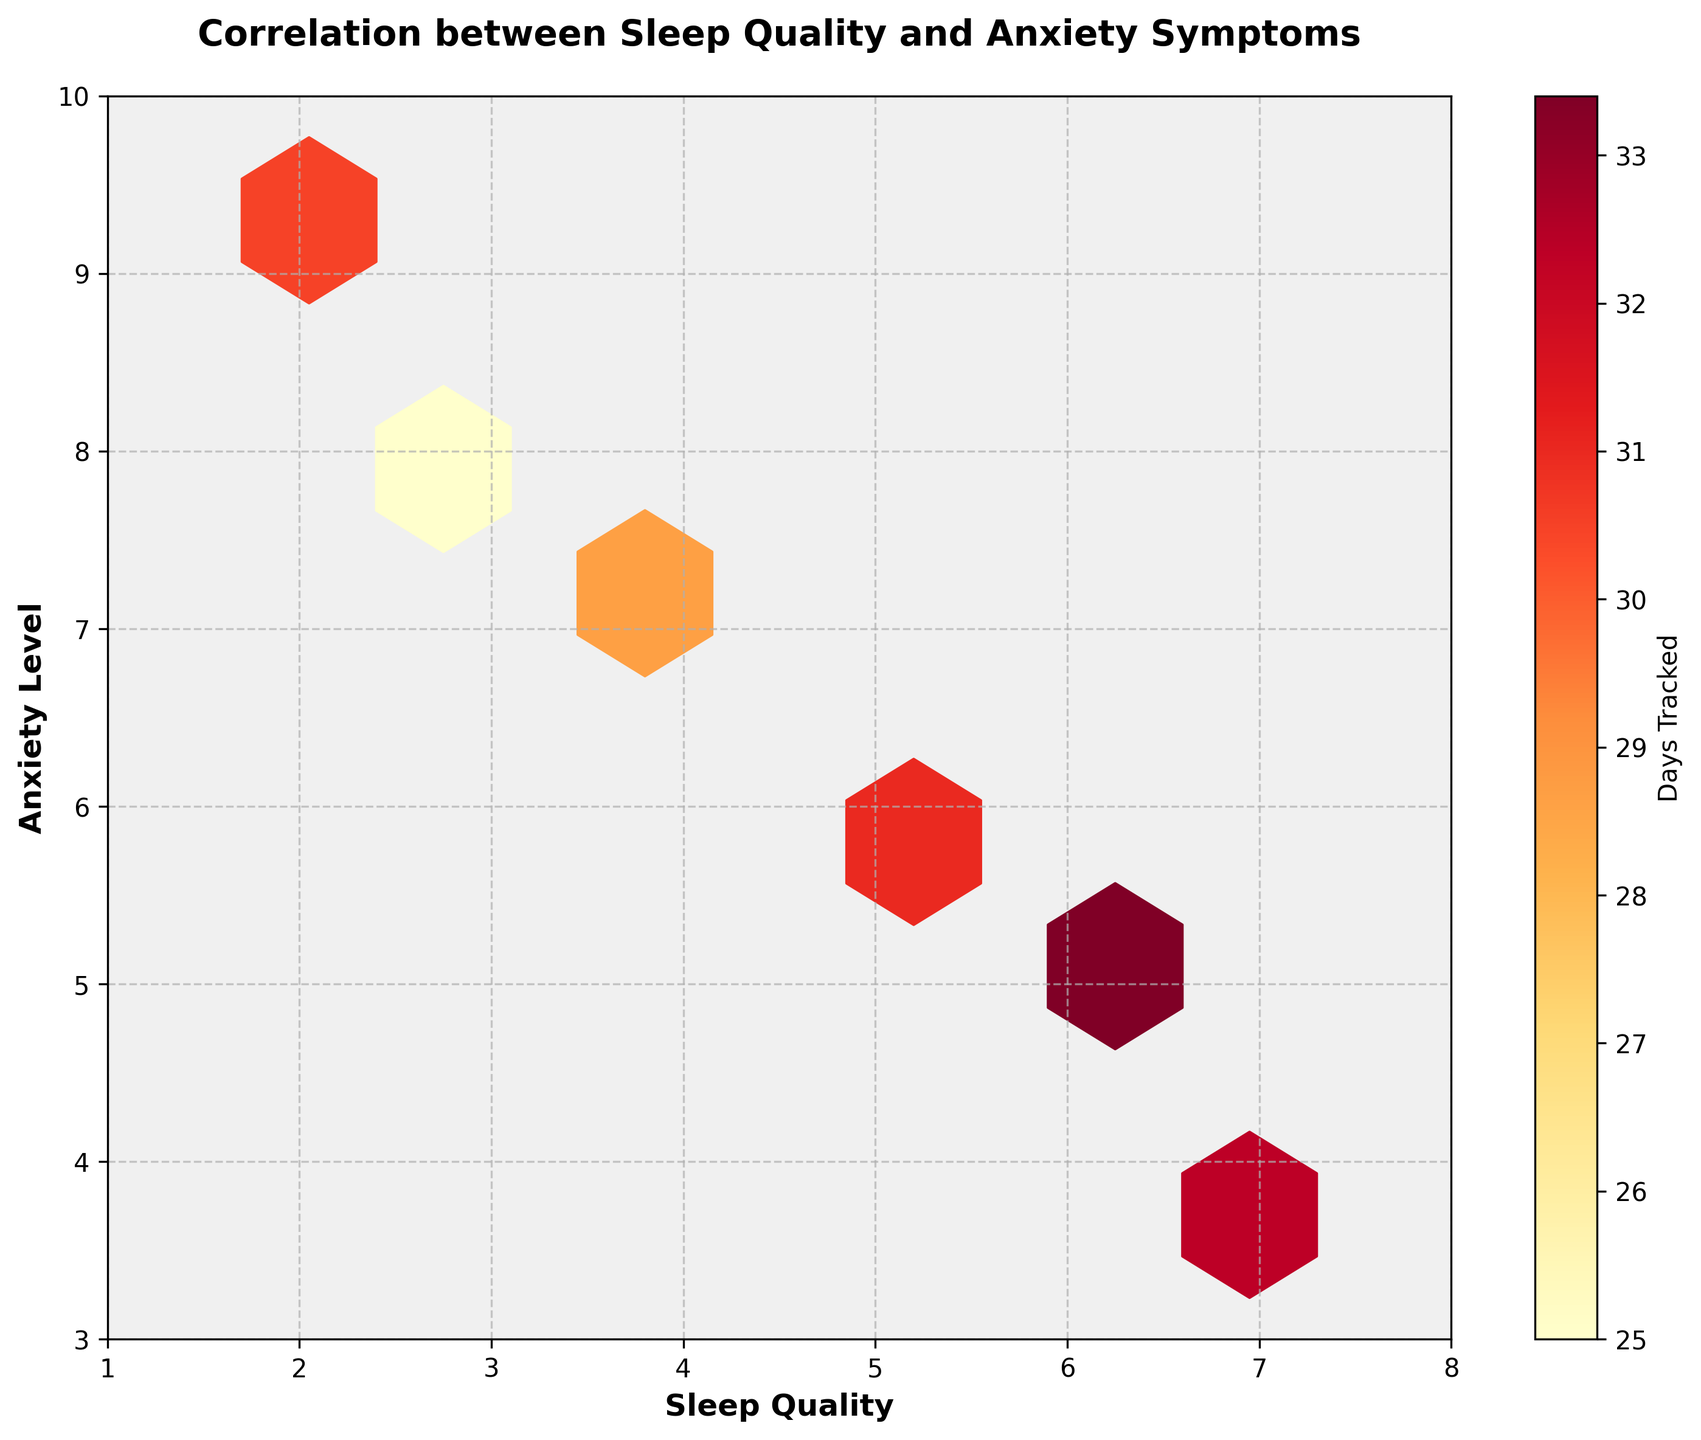What are the labels on the x-axis and y-axis? The x-axis is labeled 'Sleep Quality' and the y-axis is labeled 'Anxiety Level'.
Answer: 'Sleep Quality' and 'Anxiety Level' How many days are tracked according to the color bar? The color bar shows that the data is tracked over 'Days Tracked', and the color gradient ranges from lighter to darker shades.
Answer: 'Days Tracked' Which variable appears on the hexbin grid? 'Days Tracked' is represented on the hexbin grid, showing the density of points over the grid cells.
Answer: 'Days Tracked' What is the overall trend between sleep quality and anxiety level? The hexbin plot shows an inverse trend: as sleep quality increases, anxiety level tends to decrease. This is evident from the distribution of the hex cells.
Answer: Inverse trend Where are the highest density cells located on the hexbin plot? The highest density cells (darkest color) appear around the coordinates where sleep quality is low (2-4) and anxiety level is high (7-9).
Answer: Low sleep quality and high anxiety level How does the grid size affect the appearance of the hexbin plot? A smaller grid size would result in more detailed cells, while a larger grid size provides a more general overview of the data's density. The chosen grid size of 10 strikes a balance by not being too detailed or too general.
Answer: Moderate detail Compare the density of cells corresponding to sleep quality of 7 with those corresponding to sleep quality of 3. The cells with sleep quality of 3 have higher density (darker color) as compared to the cells with sleep quality of 7, indicating more days tracked at lower sleep quality.
Answer: 3 has higher density What can you infer about the days tracked for sleep qualities between 6 and 7? For sleep qualities between 6 and 7, the density of cells is relatively lower, indicating that fewer days were tracked with these sleep qualities and lower anxiety levels. This distribution shows fewer data points here.
Answer: Lower density What does the color of the hexagons represent in this plot? The color of the hexagons represents the number of days tracked, with darker colors indicating a higher number of days tracked.
Answer: Number of days tracked What is the general relationship between the highest sleep quality and the corresponding anxiety levels? The highest sleep quality (7) corresponds with the lower anxiety levels (4), indicating that better sleep quality is associated with lower anxiety symptoms.
Answer: Better sleep, lower anxiety 